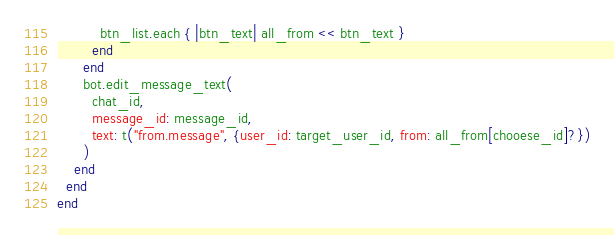<code> <loc_0><loc_0><loc_500><loc_500><_Crystal_>          btn_list.each { |btn_text| all_from << btn_text }
        end
      end
      bot.edit_message_text(
        chat_id,
        message_id: message_id,
        text: t("from.message", {user_id: target_user_id, from: all_from[chooese_id]?})
      )
    end
  end
end
</code> 